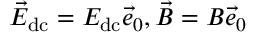Convert formula to latex. <formula><loc_0><loc_0><loc_500><loc_500>\vec { E } _ { d c } = E _ { d c } \vec { e } _ { 0 } , \vec { B } = B \vec { e } _ { 0 }</formula> 